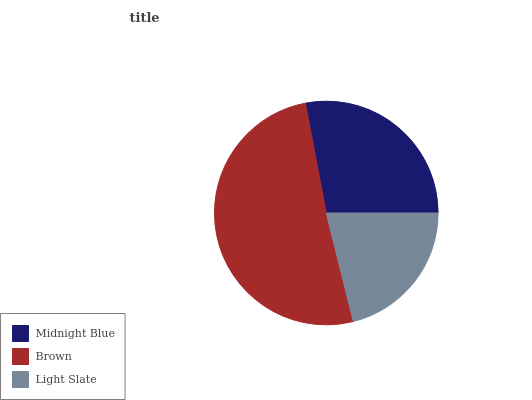Is Light Slate the minimum?
Answer yes or no. Yes. Is Brown the maximum?
Answer yes or no. Yes. Is Brown the minimum?
Answer yes or no. No. Is Light Slate the maximum?
Answer yes or no. No. Is Brown greater than Light Slate?
Answer yes or no. Yes. Is Light Slate less than Brown?
Answer yes or no. Yes. Is Light Slate greater than Brown?
Answer yes or no. No. Is Brown less than Light Slate?
Answer yes or no. No. Is Midnight Blue the high median?
Answer yes or no. Yes. Is Midnight Blue the low median?
Answer yes or no. Yes. Is Brown the high median?
Answer yes or no. No. Is Light Slate the low median?
Answer yes or no. No. 